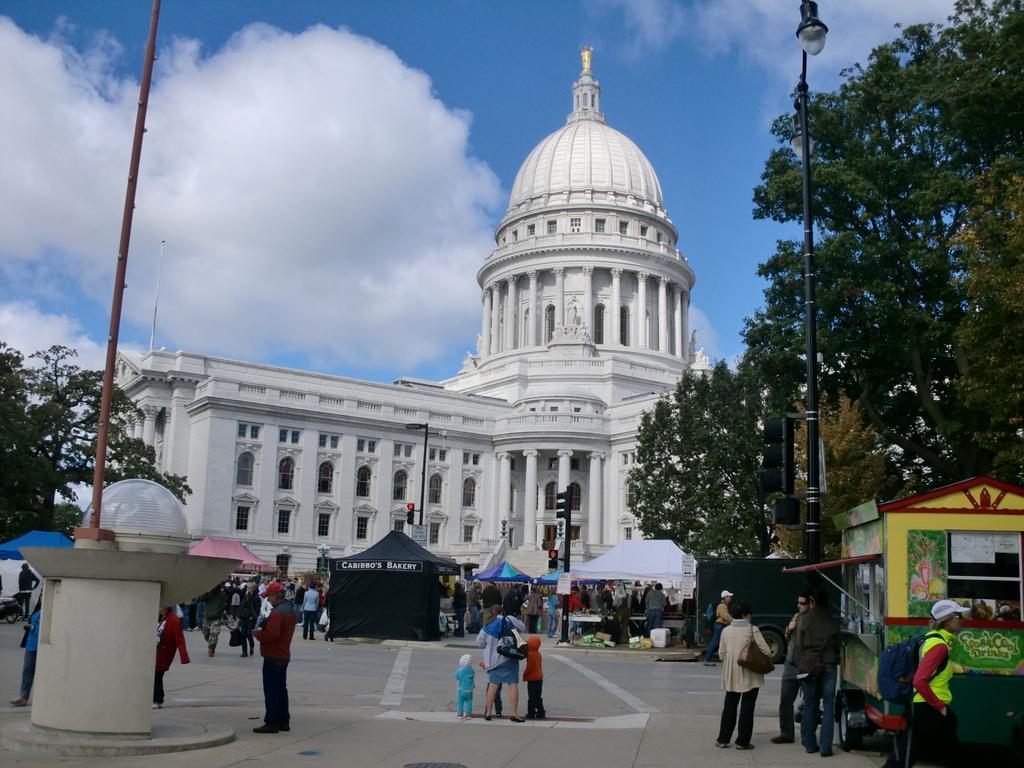In one or two sentences, can you explain what this image depicts? In this image, we can see a building, there are some people standing, there are some trees, at the top there is a blue sky and we can see some clouds. 